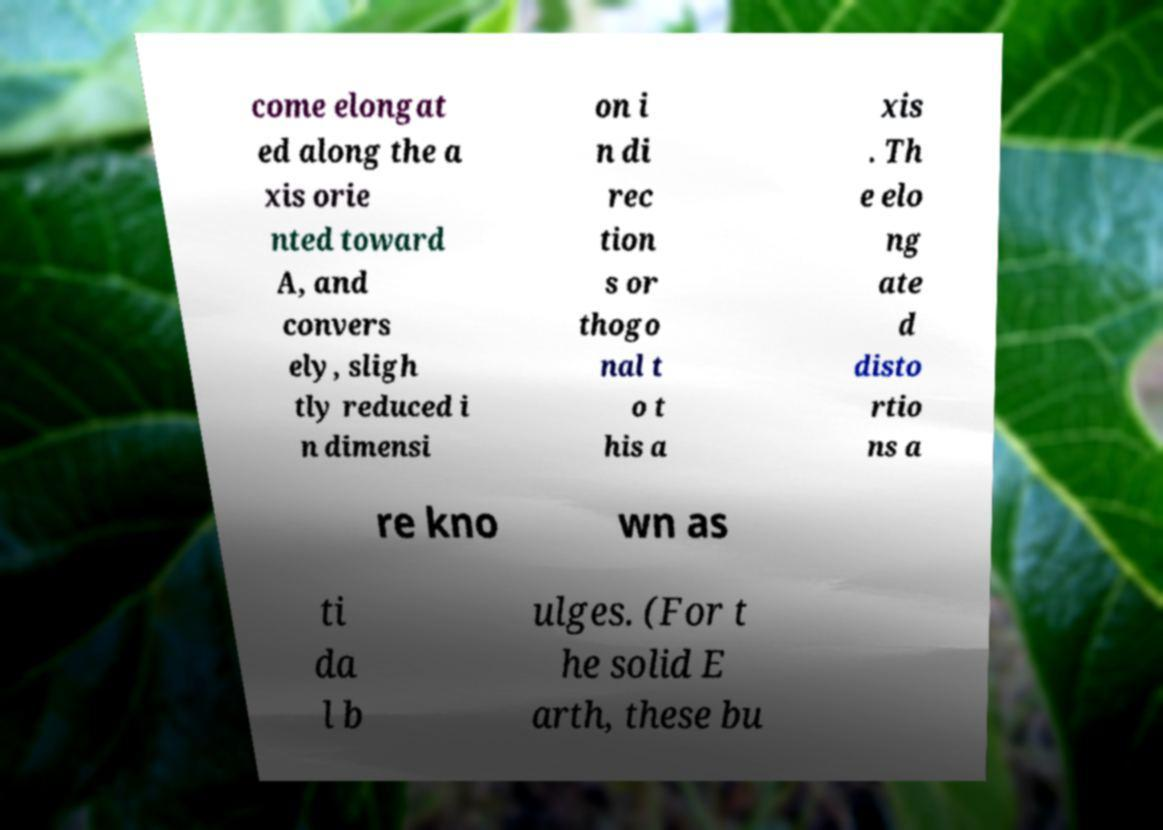For documentation purposes, I need the text within this image transcribed. Could you provide that? come elongat ed along the a xis orie nted toward A, and convers ely, sligh tly reduced i n dimensi on i n di rec tion s or thogo nal t o t his a xis . Th e elo ng ate d disto rtio ns a re kno wn as ti da l b ulges. (For t he solid E arth, these bu 